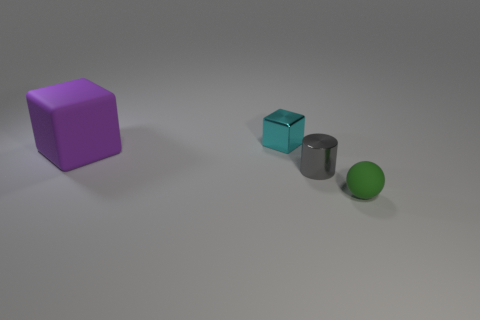What number of blocks are big matte objects or small objects?
Make the answer very short. 2. The block that is the same size as the green matte thing is what color?
Offer a terse response. Cyan. How many cubes are both on the right side of the purple matte object and in front of the small cube?
Your answer should be compact. 0. What is the big purple block made of?
Make the answer very short. Rubber. How many objects are cyan spheres or gray things?
Your response must be concise. 1. There is a metal thing that is in front of the small metallic cube; does it have the same size as the metallic object that is to the left of the gray shiny object?
Give a very brief answer. Yes. How many other things are there of the same size as the cyan object?
Your response must be concise. 2. How many objects are either tiny objects in front of the cyan metal cube or objects in front of the metallic block?
Keep it short and to the point. 3. Are the tiny cyan thing and the small object that is right of the tiny cylinder made of the same material?
Ensure brevity in your answer.  No. What number of other objects are the same shape as the tiny matte thing?
Provide a succinct answer. 0. 